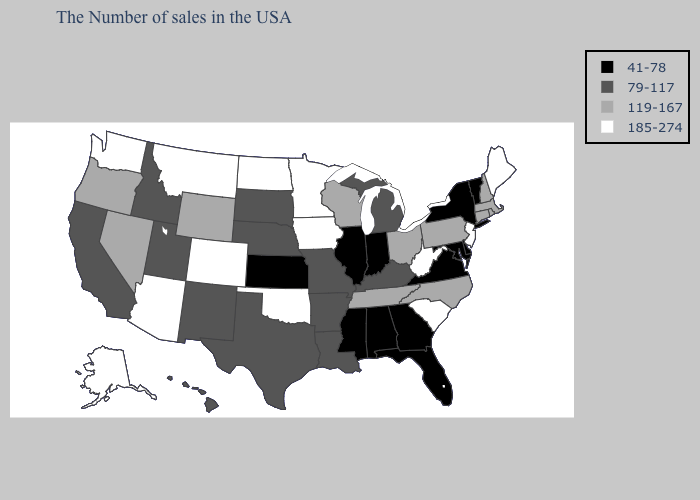Is the legend a continuous bar?
Write a very short answer. No. What is the highest value in states that border Alabama?
Concise answer only. 119-167. Which states have the highest value in the USA?
Be succinct. Maine, New Jersey, South Carolina, West Virginia, Minnesota, Iowa, Oklahoma, North Dakota, Colorado, Montana, Arizona, Washington, Alaska. Which states have the lowest value in the Northeast?
Keep it brief. Vermont, New York. Does Arkansas have a lower value than Arizona?
Keep it brief. Yes. Does the first symbol in the legend represent the smallest category?
Concise answer only. Yes. Among the states that border Connecticut , does New York have the lowest value?
Answer briefly. Yes. Does Iowa have a higher value than Florida?
Keep it brief. Yes. Which states have the highest value in the USA?
Concise answer only. Maine, New Jersey, South Carolina, West Virginia, Minnesota, Iowa, Oklahoma, North Dakota, Colorado, Montana, Arizona, Washington, Alaska. What is the lowest value in the Northeast?
Be succinct. 41-78. Does the map have missing data?
Short answer required. No. Among the states that border Alabama , does Tennessee have the highest value?
Concise answer only. Yes. What is the lowest value in states that border West Virginia?
Give a very brief answer. 41-78. Which states have the lowest value in the USA?
Write a very short answer. Vermont, New York, Delaware, Maryland, Virginia, Florida, Georgia, Indiana, Alabama, Illinois, Mississippi, Kansas. What is the lowest value in the USA?
Be succinct. 41-78. 